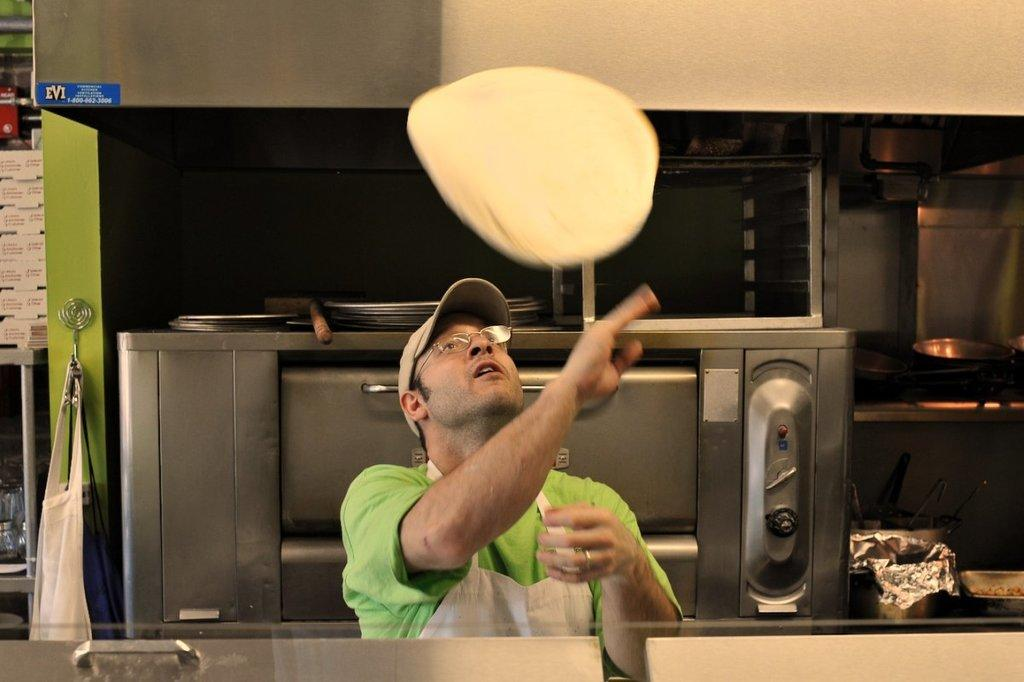What is the main subject of the image? There is a person in the image. What is the person wearing? The person is wearing a roti (possibly a cooking apron). What can be seen in the background of the image? There is a microwave oven in the background of the image. Where are the vessels located in the image? There are vessels on the top and right side of the image. What type of punishment is being administered to the person in the image? There is no indication of punishment in the image; the person is simply wearing a roti or cooking apron. What is the significance of the edge in the image? There is no specific edge mentioned in the image; the focus is on the person, their clothing, and the vessels. 